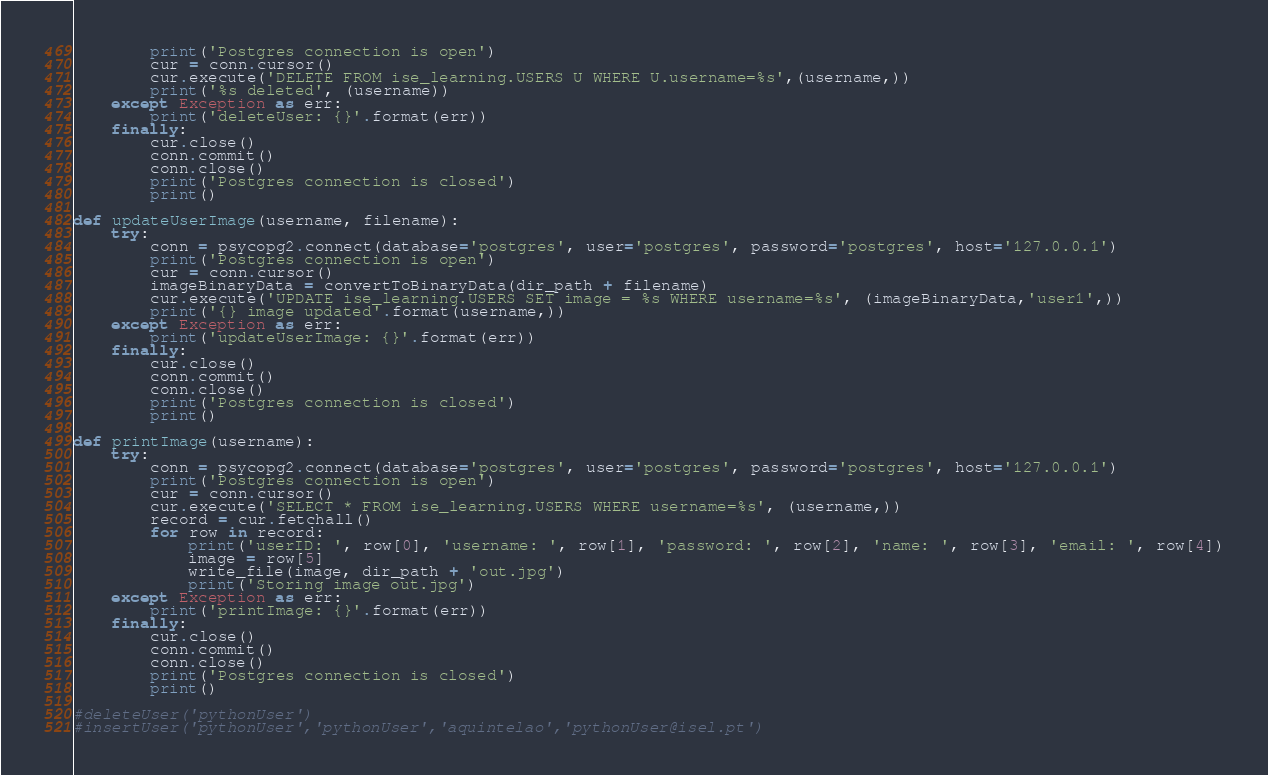Convert code to text. <code><loc_0><loc_0><loc_500><loc_500><_Python_>        print('Postgres connection is open')
        cur = conn.cursor()
        cur.execute('DELETE FROM ise_learning.USERS U WHERE U.username=%s',(username,))
        print('%s deleted', (username))
    except Exception as err:
        print('deleteUser: {}'.format(err))
    finally:
        cur.close()
        conn.commit()
        conn.close()
        print('Postgres connection is closed')
        print()

def updateUserImage(username, filename):
    try:
        conn = psycopg2.connect(database='postgres', user='postgres', password='postgres', host='127.0.0.1')
        print('Postgres connection is open')
        cur = conn.cursor()
        imageBinaryData = convertToBinaryData(dir_path + filename)
        cur.execute('UPDATE ise_learning.USERS SET image = %s WHERE username=%s', (imageBinaryData,'user1',))
        print('{} image updated'.format(username,))
    except Exception as err:
        print('updateUserImage: {}'.format(err))
    finally:
        cur.close()
        conn.commit()
        conn.close()
        print('Postgres connection is closed')
        print()

def printImage(username):
    try:
        conn = psycopg2.connect(database='postgres', user='postgres', password='postgres', host='127.0.0.1')
        print('Postgres connection is open')
        cur = conn.cursor()
        cur.execute('SELECT * FROM ise_learning.USERS WHERE username=%s', (username,))
        record = cur.fetchall()
        for row in record:
            print('userID: ', row[0], 'username: ', row[1], 'password: ', row[2], 'name: ', row[3], 'email: ', row[4])
            image = row[5]
            write_file(image, dir_path + 'out.jpg')
            print('Storing image out.jpg')
    except Exception as err:
        print('printImage: {}'.format(err))
    finally:
        cur.close()
        conn.commit()
        conn.close()
        print('Postgres connection is closed')
        print()

#deleteUser('pythonUser')
#insertUser('pythonUser','pythonUser','aquintelao','pythonUser@isel.pt')</code> 